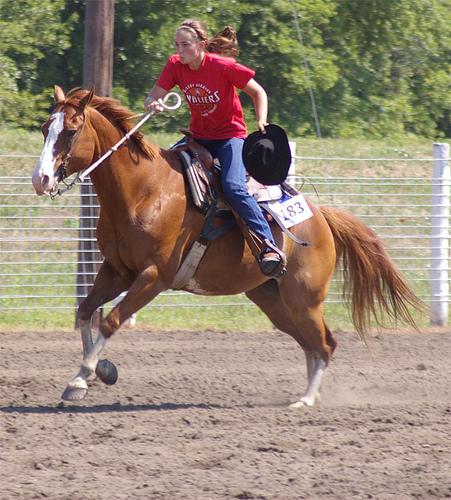What is the name for a girl or woman who rides on horseback?
Be succinct. Equestrian. What does the girl have in her hand?
Keep it brief. Hat. Is the woman wearing a riding outfit?
Short answer required. No. Is the horse galloping?
Concise answer only. Yes. Does this horse look healthy?
Be succinct. Yes. 